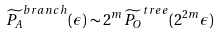<formula> <loc_0><loc_0><loc_500><loc_500>\widetilde { P _ { A } } ^ { b r a n c h } ( \epsilon ) \sim 2 ^ { m } \widetilde { P _ { O } } ^ { t r e e } ( 2 ^ { 2 m } \epsilon )</formula> 